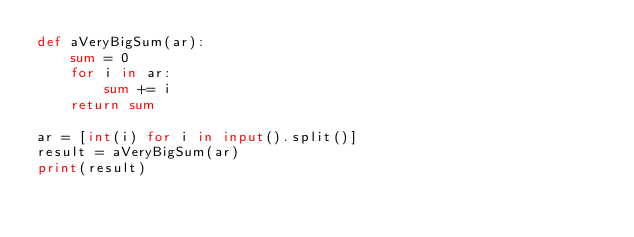Convert code to text. <code><loc_0><loc_0><loc_500><loc_500><_Python_>def aVeryBigSum(ar):
	sum = 0
	for i in ar:
		sum += i
	return sum

ar = [int(i) for i in input().split()]
result = aVeryBigSum(ar)
print(result)
</code> 